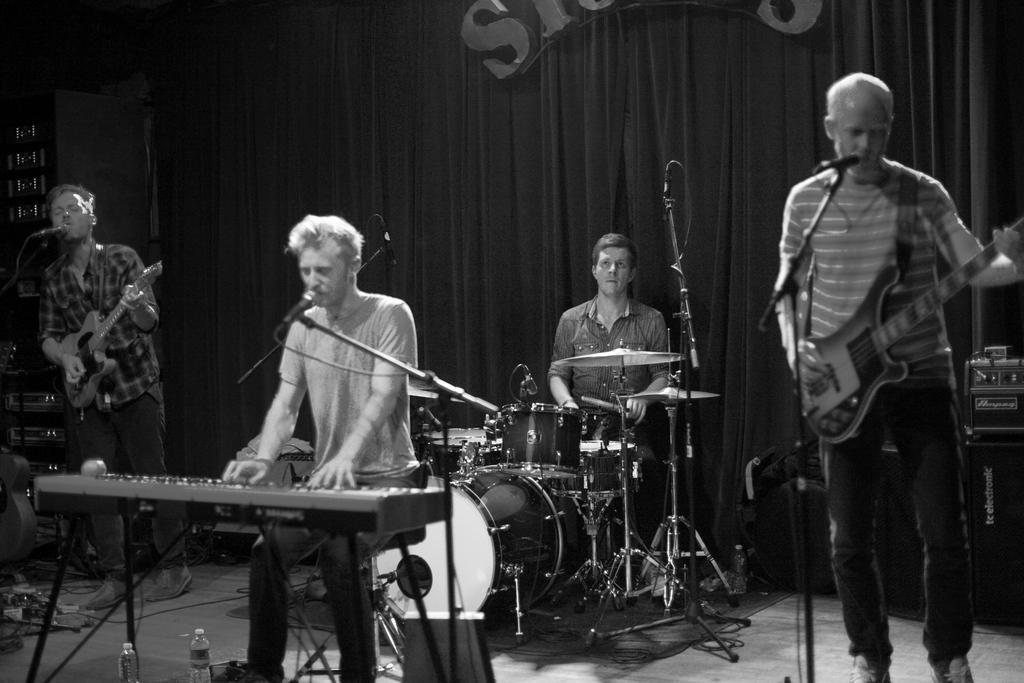Please provide a concise description of this image. A rock band is performing. A man is singing while playing keyboard in the front. There are two men on either side playing guitar and giving chorus. There is a man behind playing the drums. 